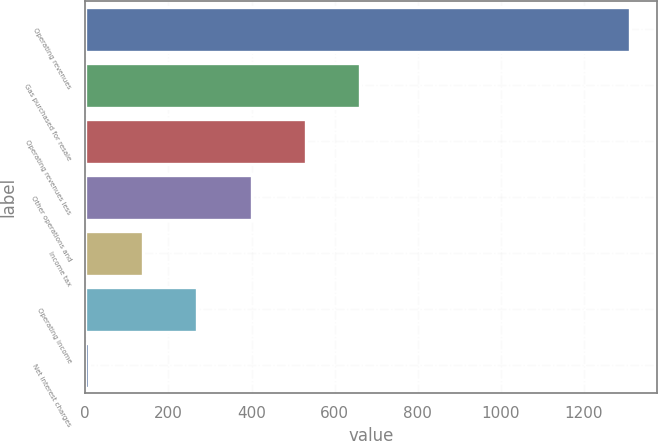<chart> <loc_0><loc_0><loc_500><loc_500><bar_chart><fcel>Operating revenues<fcel>Gas purchased for resale<fcel>Operating revenues less<fcel>Other operations and<fcel>Income tax<fcel>Operating income<fcel>Net interest charges<nl><fcel>1310<fcel>660<fcel>530<fcel>400<fcel>140<fcel>270<fcel>10<nl></chart> 